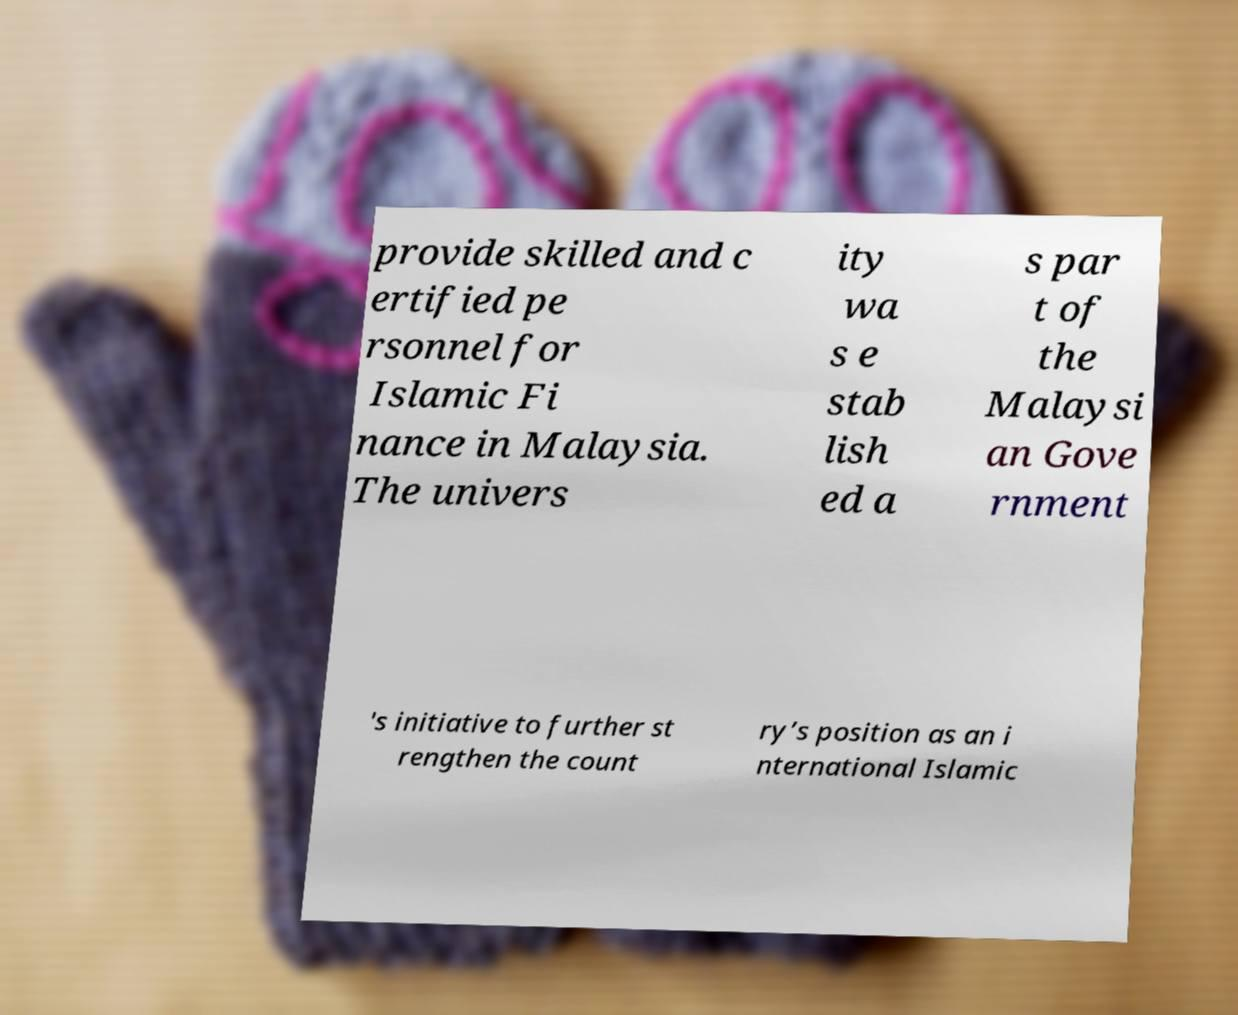I need the written content from this picture converted into text. Can you do that? provide skilled and c ertified pe rsonnel for Islamic Fi nance in Malaysia. The univers ity wa s e stab lish ed a s par t of the Malaysi an Gove rnment 's initiative to further st rengthen the count ry’s position as an i nternational Islamic 